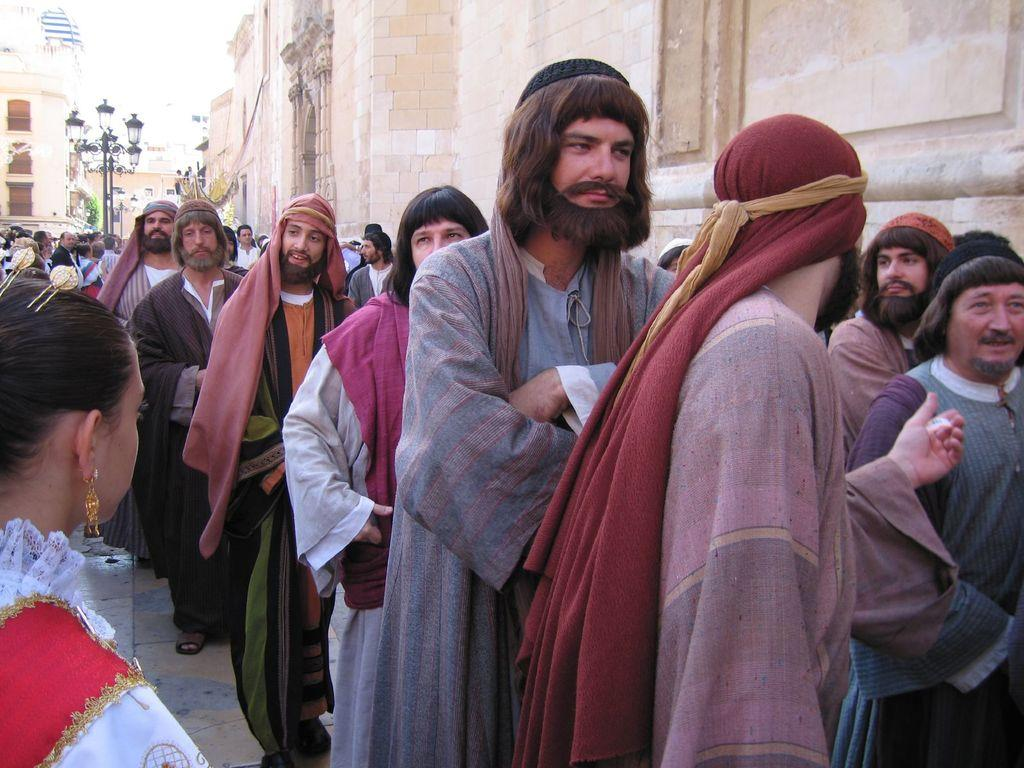What are the people in the image doing? The people in the image are standing in a line. What can be seen in the background of the image? There are buildings in the image. What type of lighting is present on the road in the image? There is a street lamp visible on the road in the image. What type of roof can be seen on the buildings in the image? There is no specific roof type mentioned in the facts provided, and the image does not show a close-up view of the buildings' roofs. 